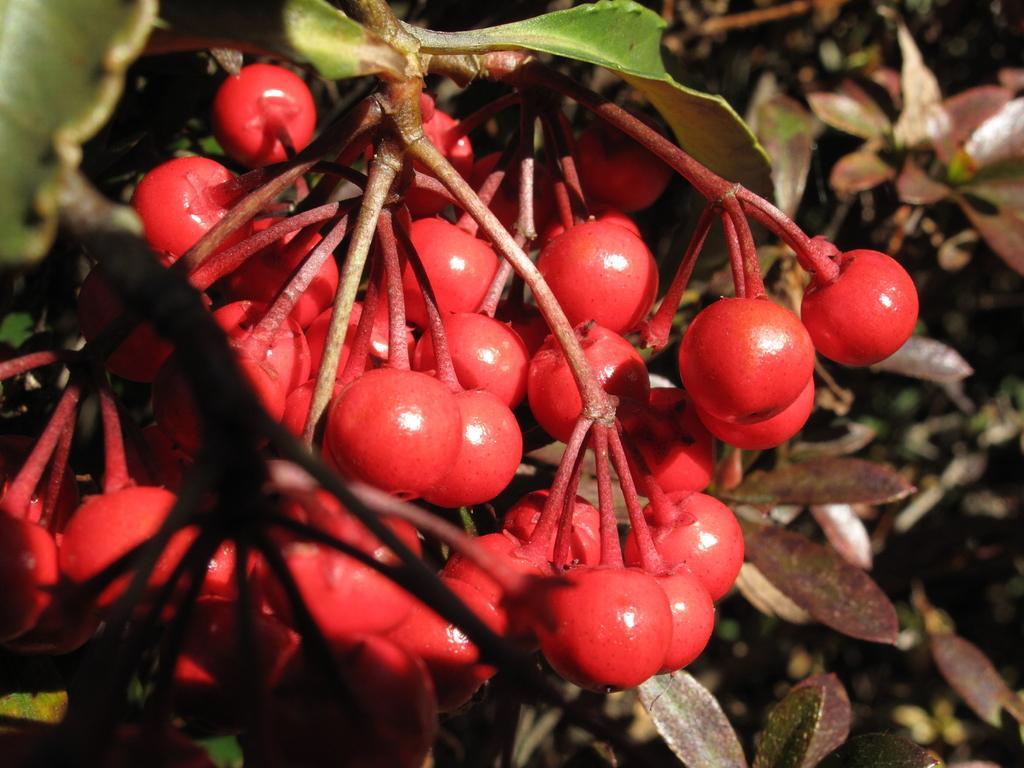Describe this image in one or two sentences. In this image we can see a bunch of cherries to the tree. 